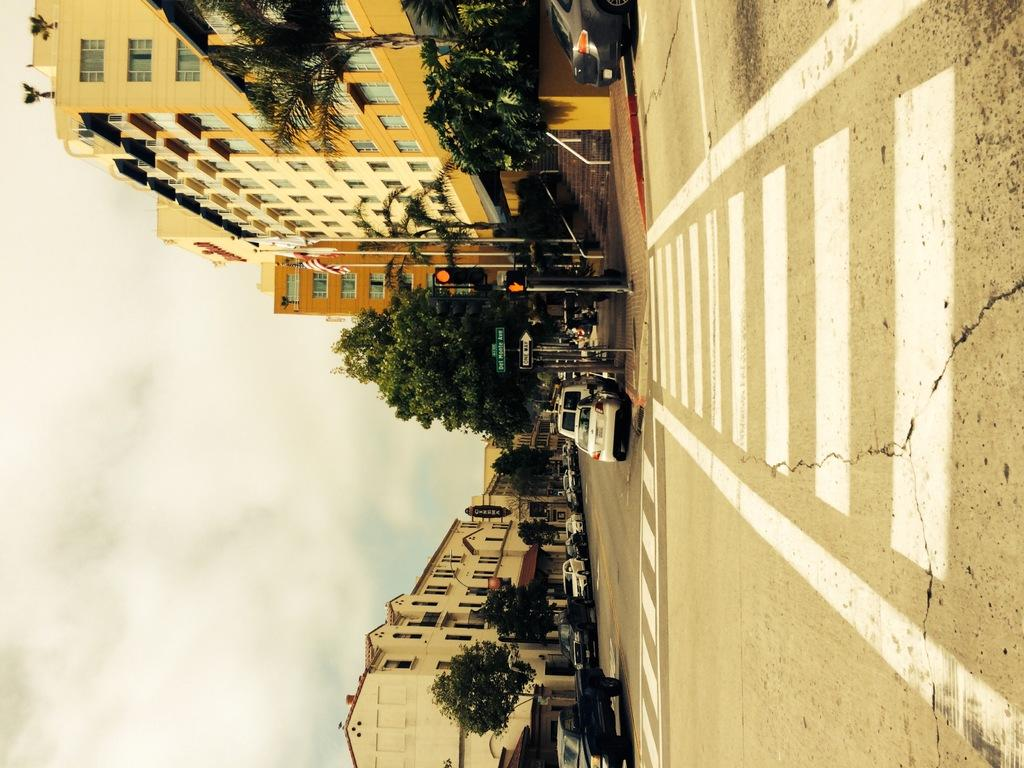What is happening on the road in the image? Cars are passing on the road in the image. What helps regulate the traffic on the road? There are traffic lights on either side of the road. What information might be conveyed to drivers in the image? Sign boards are present on either side of the road. What type of vegetation can be seen on either side of the road? Trees are visible on either side of the road. What type of structures are present in the image? Buildings are present in the image. What type of twig is being used to oil the cars in the image? There is no twig or oiling of cars present in the image. Where is the bed located in the image? There is no bed present in the image. 